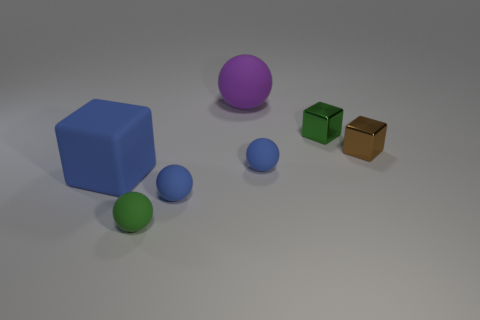Add 1 small purple rubber objects. How many objects exist? 8 Subtract all purple balls. How many balls are left? 3 Add 3 brown shiny cubes. How many brown shiny cubes exist? 4 Subtract all purple balls. How many balls are left? 3 Subtract 0 purple cylinders. How many objects are left? 7 Subtract all spheres. How many objects are left? 3 Subtract 2 balls. How many balls are left? 2 Subtract all red spheres. Subtract all red cylinders. How many spheres are left? 4 Subtract all yellow blocks. How many cyan balls are left? 0 Subtract all small blue balls. Subtract all brown shiny things. How many objects are left? 4 